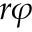Convert formula to latex. <formula><loc_0><loc_0><loc_500><loc_500>r \varphi</formula> 